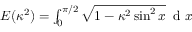Convert formula to latex. <formula><loc_0><loc_0><loc_500><loc_500>\begin{array} { r } { E ( \kappa ^ { 2 } ) = \int _ { 0 } ^ { \pi / 2 } \sqrt { 1 - \kappa ^ { 2 } \sin ^ { 2 } x } \, d x } \end{array}</formula> 